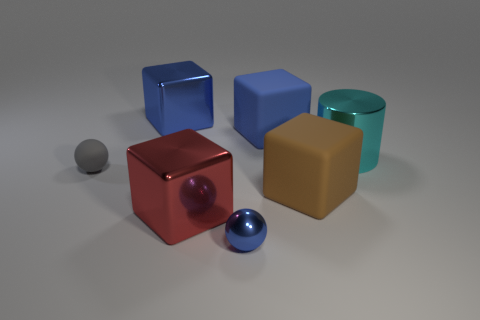Subtract all blue blocks. How many were subtracted if there are1blue blocks left? 1 Add 2 blue balls. How many objects exist? 9 Subtract all balls. How many objects are left? 5 Subtract 0 purple cylinders. How many objects are left? 7 Subtract all brown things. Subtract all large things. How many objects are left? 1 Add 7 rubber spheres. How many rubber spheres are left? 8 Add 4 purple rubber cubes. How many purple rubber cubes exist? 4 